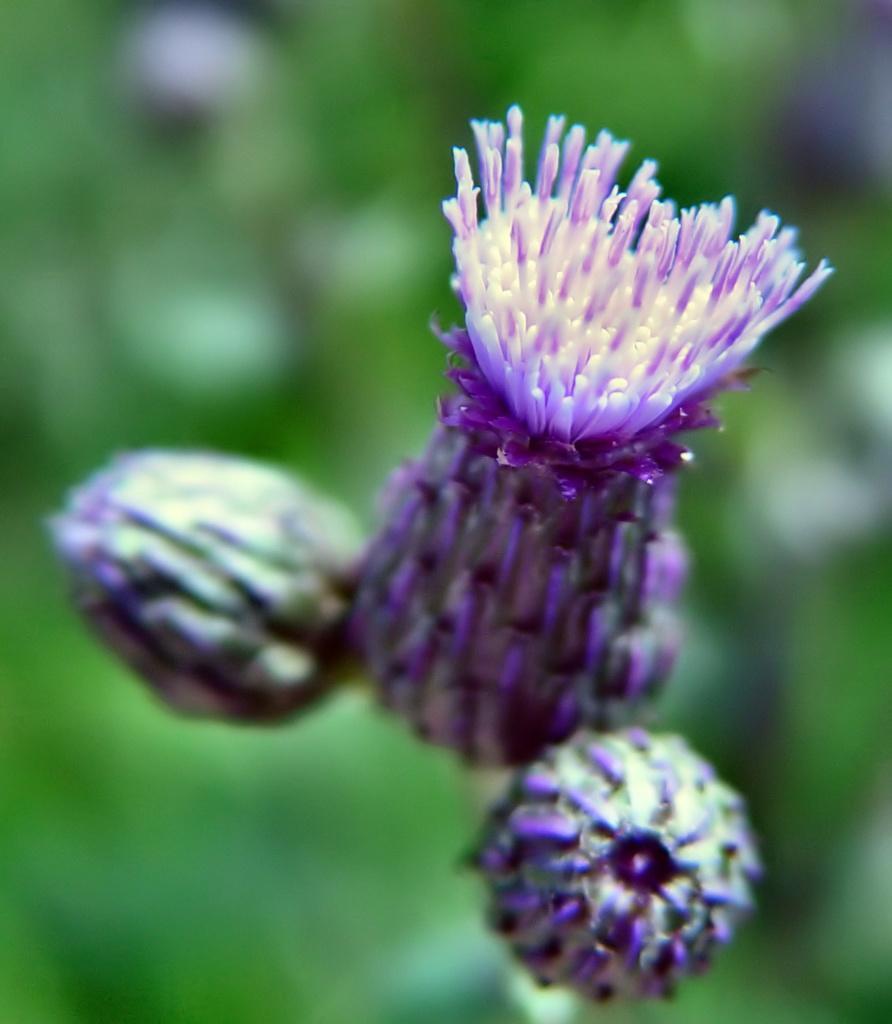In one or two sentences, can you explain what this image depicts? In this image, we can see a flower and flower buds. Background we can see a blur view. Here we can see greenery. 